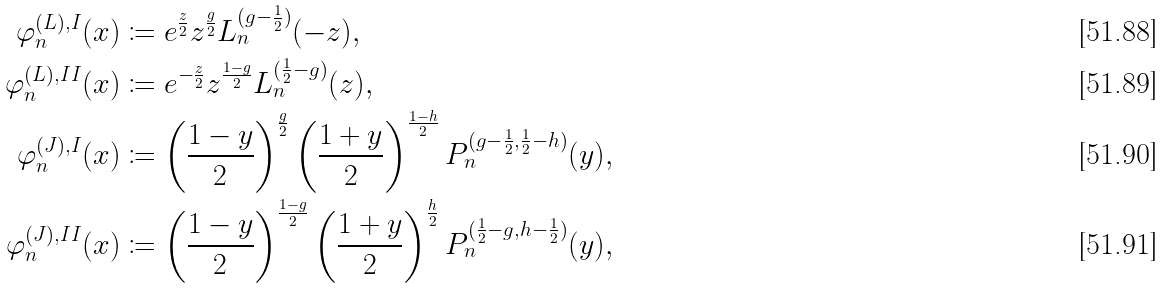Convert formula to latex. <formula><loc_0><loc_0><loc_500><loc_500>\varphi _ { n } ^ { ( L ) , I } ( x ) & \coloneqq e ^ { \frac { z } { 2 } } z ^ { \frac { g } { 2 } } L _ { n } ^ { ( g - \frac { 1 } { 2 } ) } ( - z ) , \\ \varphi _ { n } ^ { ( L ) , I I } ( x ) & \coloneqq e ^ { - \frac { z } { 2 } } z ^ { \frac { 1 - g } { 2 } } L _ { n } ^ { ( \frac { 1 } { 2 } - g ) } ( z ) , \\ \varphi _ { n } ^ { ( J ) , I } ( x ) & \coloneqq \left ( \frac { 1 - y } { 2 } \right ) ^ { \frac { g } { 2 } } \left ( \frac { 1 + y } { 2 } \right ) ^ { \frac { 1 - h } { 2 } } P _ { n } ^ { ( g - \frac { 1 } { 2 } , \frac { 1 } { 2 } - h ) } ( y ) , \\ \varphi _ { n } ^ { ( J ) , I I } ( x ) & \coloneqq \left ( \frac { 1 - y } { 2 } \right ) ^ { \frac { 1 - g } { 2 } } \left ( \frac { 1 + y } { 2 } \right ) ^ { \frac { h } { 2 } } P _ { n } ^ { ( \frac { 1 } { 2 } - g , h - \frac { 1 } { 2 } ) } ( y ) ,</formula> 